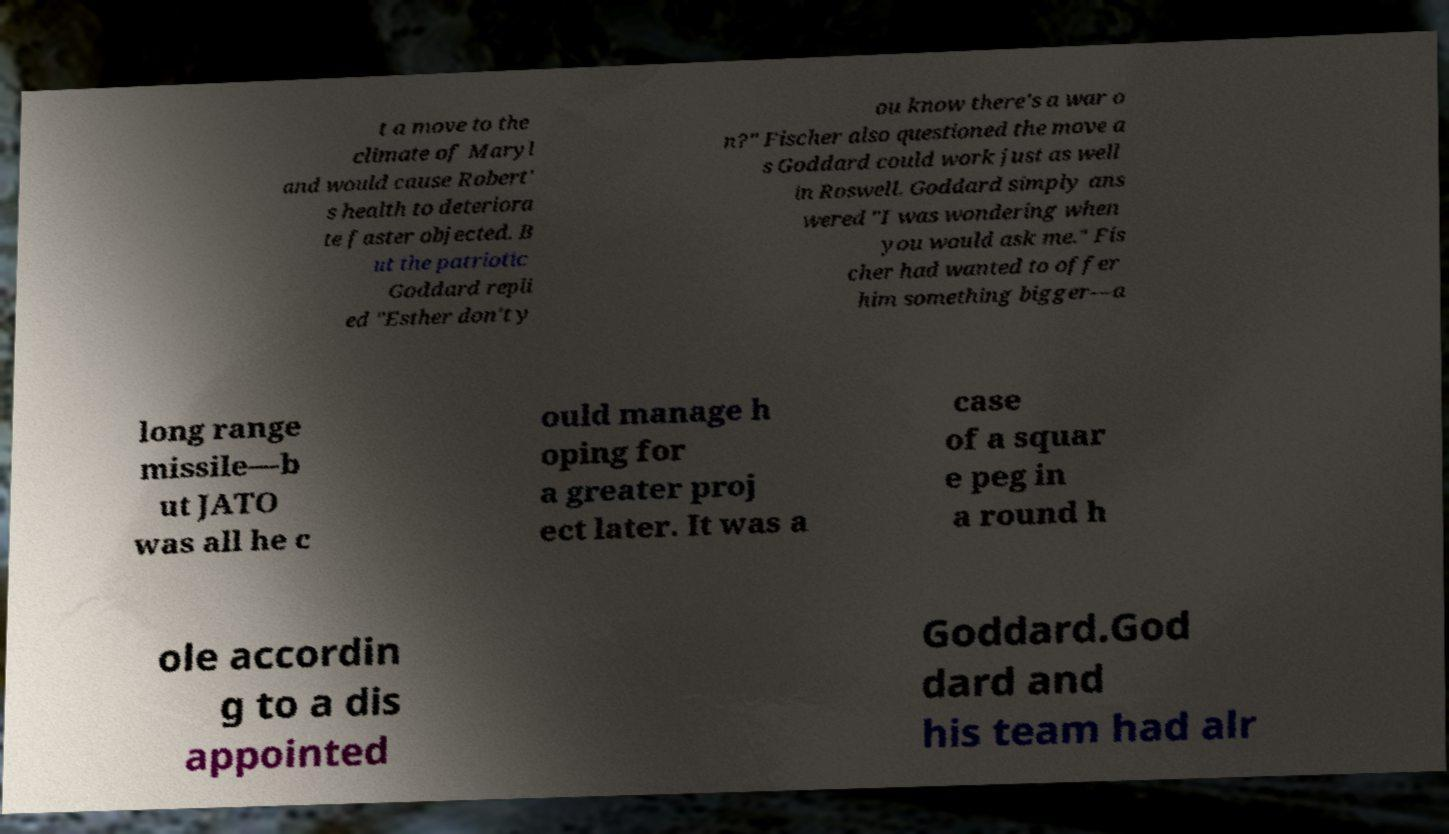Please read and relay the text visible in this image. What does it say? t a move to the climate of Maryl and would cause Robert' s health to deteriora te faster objected. B ut the patriotic Goddard repli ed "Esther don't y ou know there's a war o n?" Fischer also questioned the move a s Goddard could work just as well in Roswell. Goddard simply ans wered "I was wondering when you would ask me." Fis cher had wanted to offer him something bigger—a long range missile—b ut JATO was all he c ould manage h oping for a greater proj ect later. It was a case of a squar e peg in a round h ole accordin g to a dis appointed Goddard.God dard and his team had alr 